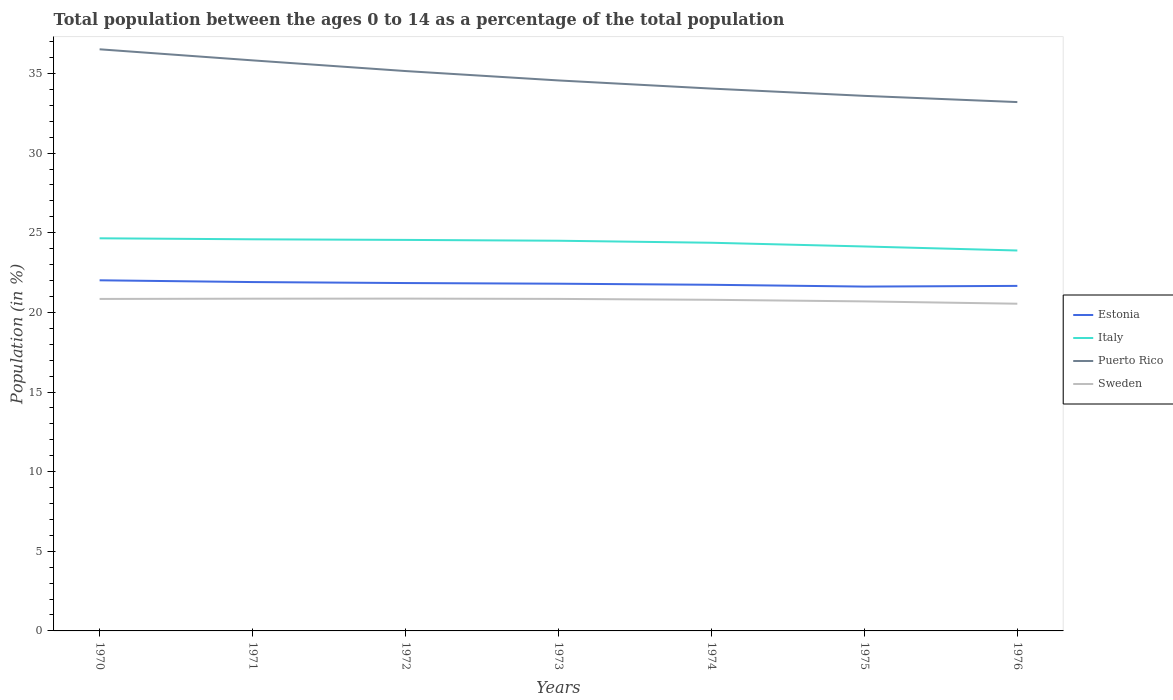Is the number of lines equal to the number of legend labels?
Keep it short and to the point. Yes. Across all years, what is the maximum percentage of the population ages 0 to 14 in Sweden?
Give a very brief answer. 20.55. In which year was the percentage of the population ages 0 to 14 in Estonia maximum?
Your answer should be very brief. 1975. What is the total percentage of the population ages 0 to 14 in Sweden in the graph?
Your answer should be very brief. 0.16. What is the difference between the highest and the second highest percentage of the population ages 0 to 14 in Puerto Rico?
Give a very brief answer. 3.31. What is the difference between the highest and the lowest percentage of the population ages 0 to 14 in Estonia?
Ensure brevity in your answer.  4. Is the percentage of the population ages 0 to 14 in Italy strictly greater than the percentage of the population ages 0 to 14 in Sweden over the years?
Give a very brief answer. No. How many years are there in the graph?
Your response must be concise. 7. Does the graph contain any zero values?
Your response must be concise. No. Where does the legend appear in the graph?
Your response must be concise. Center right. How many legend labels are there?
Offer a terse response. 4. How are the legend labels stacked?
Give a very brief answer. Vertical. What is the title of the graph?
Provide a succinct answer. Total population between the ages 0 to 14 as a percentage of the total population. What is the label or title of the X-axis?
Provide a short and direct response. Years. What is the label or title of the Y-axis?
Keep it short and to the point. Population (in %). What is the Population (in %) of Estonia in 1970?
Make the answer very short. 22.02. What is the Population (in %) of Italy in 1970?
Ensure brevity in your answer.  24.65. What is the Population (in %) in Puerto Rico in 1970?
Make the answer very short. 36.52. What is the Population (in %) of Sweden in 1970?
Provide a succinct answer. 20.85. What is the Population (in %) in Estonia in 1971?
Keep it short and to the point. 21.9. What is the Population (in %) in Italy in 1971?
Keep it short and to the point. 24.59. What is the Population (in %) in Puerto Rico in 1971?
Your answer should be very brief. 35.83. What is the Population (in %) in Sweden in 1971?
Offer a very short reply. 20.86. What is the Population (in %) of Estonia in 1972?
Make the answer very short. 21.84. What is the Population (in %) of Italy in 1972?
Your response must be concise. 24.55. What is the Population (in %) of Puerto Rico in 1972?
Offer a terse response. 35.15. What is the Population (in %) of Sweden in 1972?
Your response must be concise. 20.87. What is the Population (in %) of Estonia in 1973?
Ensure brevity in your answer.  21.8. What is the Population (in %) in Italy in 1973?
Make the answer very short. 24.5. What is the Population (in %) of Puerto Rico in 1973?
Make the answer very short. 34.56. What is the Population (in %) in Sweden in 1973?
Keep it short and to the point. 20.85. What is the Population (in %) of Estonia in 1974?
Ensure brevity in your answer.  21.73. What is the Population (in %) of Italy in 1974?
Offer a terse response. 24.37. What is the Population (in %) in Puerto Rico in 1974?
Your answer should be very brief. 34.05. What is the Population (in %) in Sweden in 1974?
Provide a succinct answer. 20.79. What is the Population (in %) of Estonia in 1975?
Keep it short and to the point. 21.62. What is the Population (in %) in Italy in 1975?
Keep it short and to the point. 24.14. What is the Population (in %) of Puerto Rico in 1975?
Your response must be concise. 33.6. What is the Population (in %) in Sweden in 1975?
Make the answer very short. 20.69. What is the Population (in %) in Estonia in 1976?
Ensure brevity in your answer.  21.66. What is the Population (in %) of Italy in 1976?
Your answer should be compact. 23.89. What is the Population (in %) in Puerto Rico in 1976?
Your answer should be compact. 33.21. What is the Population (in %) in Sweden in 1976?
Ensure brevity in your answer.  20.55. Across all years, what is the maximum Population (in %) in Estonia?
Make the answer very short. 22.02. Across all years, what is the maximum Population (in %) of Italy?
Your answer should be very brief. 24.65. Across all years, what is the maximum Population (in %) in Puerto Rico?
Keep it short and to the point. 36.52. Across all years, what is the maximum Population (in %) in Sweden?
Offer a very short reply. 20.87. Across all years, what is the minimum Population (in %) of Estonia?
Your answer should be very brief. 21.62. Across all years, what is the minimum Population (in %) of Italy?
Ensure brevity in your answer.  23.89. Across all years, what is the minimum Population (in %) in Puerto Rico?
Your response must be concise. 33.21. Across all years, what is the minimum Population (in %) in Sweden?
Offer a very short reply. 20.55. What is the total Population (in %) of Estonia in the graph?
Give a very brief answer. 152.58. What is the total Population (in %) of Italy in the graph?
Make the answer very short. 170.7. What is the total Population (in %) in Puerto Rico in the graph?
Keep it short and to the point. 242.92. What is the total Population (in %) in Sweden in the graph?
Offer a terse response. 145.45. What is the difference between the Population (in %) of Estonia in 1970 and that in 1971?
Offer a very short reply. 0.11. What is the difference between the Population (in %) of Italy in 1970 and that in 1971?
Offer a terse response. 0.06. What is the difference between the Population (in %) in Puerto Rico in 1970 and that in 1971?
Provide a short and direct response. 0.7. What is the difference between the Population (in %) in Sweden in 1970 and that in 1971?
Keep it short and to the point. -0.02. What is the difference between the Population (in %) in Estonia in 1970 and that in 1972?
Your answer should be very brief. 0.17. What is the difference between the Population (in %) in Italy in 1970 and that in 1972?
Provide a succinct answer. 0.1. What is the difference between the Population (in %) in Puerto Rico in 1970 and that in 1972?
Your answer should be very brief. 1.37. What is the difference between the Population (in %) in Sweden in 1970 and that in 1972?
Make the answer very short. -0.02. What is the difference between the Population (in %) of Estonia in 1970 and that in 1973?
Provide a succinct answer. 0.21. What is the difference between the Population (in %) of Italy in 1970 and that in 1973?
Keep it short and to the point. 0.15. What is the difference between the Population (in %) of Puerto Rico in 1970 and that in 1973?
Offer a very short reply. 1.96. What is the difference between the Population (in %) in Sweden in 1970 and that in 1973?
Your answer should be very brief. -0. What is the difference between the Population (in %) of Estonia in 1970 and that in 1974?
Provide a short and direct response. 0.28. What is the difference between the Population (in %) of Italy in 1970 and that in 1974?
Provide a succinct answer. 0.28. What is the difference between the Population (in %) in Puerto Rico in 1970 and that in 1974?
Your answer should be very brief. 2.47. What is the difference between the Population (in %) in Sweden in 1970 and that in 1974?
Ensure brevity in your answer.  0.05. What is the difference between the Population (in %) of Estonia in 1970 and that in 1975?
Provide a short and direct response. 0.39. What is the difference between the Population (in %) in Italy in 1970 and that in 1975?
Provide a succinct answer. 0.51. What is the difference between the Population (in %) of Puerto Rico in 1970 and that in 1975?
Your answer should be very brief. 2.92. What is the difference between the Population (in %) in Sweden in 1970 and that in 1975?
Make the answer very short. 0.15. What is the difference between the Population (in %) in Estonia in 1970 and that in 1976?
Keep it short and to the point. 0.35. What is the difference between the Population (in %) of Italy in 1970 and that in 1976?
Your answer should be compact. 0.77. What is the difference between the Population (in %) in Puerto Rico in 1970 and that in 1976?
Keep it short and to the point. 3.31. What is the difference between the Population (in %) of Sweden in 1970 and that in 1976?
Make the answer very short. 0.3. What is the difference between the Population (in %) of Estonia in 1971 and that in 1972?
Provide a short and direct response. 0.06. What is the difference between the Population (in %) of Italy in 1971 and that in 1972?
Give a very brief answer. 0.04. What is the difference between the Population (in %) in Puerto Rico in 1971 and that in 1972?
Provide a succinct answer. 0.67. What is the difference between the Population (in %) in Sweden in 1971 and that in 1972?
Provide a succinct answer. -0.01. What is the difference between the Population (in %) of Estonia in 1971 and that in 1973?
Provide a succinct answer. 0.1. What is the difference between the Population (in %) in Italy in 1971 and that in 1973?
Your response must be concise. 0.09. What is the difference between the Population (in %) of Puerto Rico in 1971 and that in 1973?
Your answer should be compact. 1.26. What is the difference between the Population (in %) of Sweden in 1971 and that in 1973?
Your answer should be compact. 0.01. What is the difference between the Population (in %) in Estonia in 1971 and that in 1974?
Provide a succinct answer. 0.17. What is the difference between the Population (in %) in Italy in 1971 and that in 1974?
Provide a short and direct response. 0.22. What is the difference between the Population (in %) in Puerto Rico in 1971 and that in 1974?
Provide a succinct answer. 1.77. What is the difference between the Population (in %) in Sweden in 1971 and that in 1974?
Make the answer very short. 0.07. What is the difference between the Population (in %) in Estonia in 1971 and that in 1975?
Your answer should be very brief. 0.28. What is the difference between the Population (in %) in Italy in 1971 and that in 1975?
Give a very brief answer. 0.45. What is the difference between the Population (in %) of Puerto Rico in 1971 and that in 1975?
Offer a very short reply. 2.23. What is the difference between the Population (in %) of Sweden in 1971 and that in 1975?
Keep it short and to the point. 0.17. What is the difference between the Population (in %) of Estonia in 1971 and that in 1976?
Provide a short and direct response. 0.24. What is the difference between the Population (in %) in Italy in 1971 and that in 1976?
Your answer should be compact. 0.7. What is the difference between the Population (in %) in Puerto Rico in 1971 and that in 1976?
Offer a very short reply. 2.62. What is the difference between the Population (in %) in Sweden in 1971 and that in 1976?
Offer a terse response. 0.32. What is the difference between the Population (in %) of Estonia in 1972 and that in 1973?
Offer a terse response. 0.04. What is the difference between the Population (in %) in Italy in 1972 and that in 1973?
Your answer should be very brief. 0.05. What is the difference between the Population (in %) of Puerto Rico in 1972 and that in 1973?
Make the answer very short. 0.59. What is the difference between the Population (in %) in Sweden in 1972 and that in 1973?
Make the answer very short. 0.02. What is the difference between the Population (in %) of Estonia in 1972 and that in 1974?
Keep it short and to the point. 0.11. What is the difference between the Population (in %) in Italy in 1972 and that in 1974?
Keep it short and to the point. 0.18. What is the difference between the Population (in %) of Puerto Rico in 1972 and that in 1974?
Offer a very short reply. 1.1. What is the difference between the Population (in %) in Sweden in 1972 and that in 1974?
Your answer should be compact. 0.07. What is the difference between the Population (in %) in Estonia in 1972 and that in 1975?
Keep it short and to the point. 0.22. What is the difference between the Population (in %) in Italy in 1972 and that in 1975?
Offer a terse response. 0.41. What is the difference between the Population (in %) in Puerto Rico in 1972 and that in 1975?
Ensure brevity in your answer.  1.56. What is the difference between the Population (in %) in Sweden in 1972 and that in 1975?
Keep it short and to the point. 0.17. What is the difference between the Population (in %) of Estonia in 1972 and that in 1976?
Your answer should be compact. 0.18. What is the difference between the Population (in %) in Italy in 1972 and that in 1976?
Your response must be concise. 0.67. What is the difference between the Population (in %) of Puerto Rico in 1972 and that in 1976?
Provide a succinct answer. 1.95. What is the difference between the Population (in %) in Sweden in 1972 and that in 1976?
Provide a short and direct response. 0.32. What is the difference between the Population (in %) of Estonia in 1973 and that in 1974?
Make the answer very short. 0.07. What is the difference between the Population (in %) of Italy in 1973 and that in 1974?
Your response must be concise. 0.13. What is the difference between the Population (in %) in Puerto Rico in 1973 and that in 1974?
Ensure brevity in your answer.  0.51. What is the difference between the Population (in %) of Sweden in 1973 and that in 1974?
Your answer should be very brief. 0.06. What is the difference between the Population (in %) of Estonia in 1973 and that in 1975?
Give a very brief answer. 0.18. What is the difference between the Population (in %) of Italy in 1973 and that in 1975?
Make the answer very short. 0.36. What is the difference between the Population (in %) in Puerto Rico in 1973 and that in 1975?
Offer a very short reply. 0.97. What is the difference between the Population (in %) in Sweden in 1973 and that in 1975?
Offer a very short reply. 0.16. What is the difference between the Population (in %) of Estonia in 1973 and that in 1976?
Provide a succinct answer. 0.14. What is the difference between the Population (in %) of Italy in 1973 and that in 1976?
Offer a very short reply. 0.61. What is the difference between the Population (in %) of Puerto Rico in 1973 and that in 1976?
Keep it short and to the point. 1.36. What is the difference between the Population (in %) of Sweden in 1973 and that in 1976?
Offer a terse response. 0.3. What is the difference between the Population (in %) in Estonia in 1974 and that in 1975?
Provide a short and direct response. 0.11. What is the difference between the Population (in %) of Italy in 1974 and that in 1975?
Ensure brevity in your answer.  0.23. What is the difference between the Population (in %) of Puerto Rico in 1974 and that in 1975?
Offer a terse response. 0.46. What is the difference between the Population (in %) in Sweden in 1974 and that in 1975?
Give a very brief answer. 0.1. What is the difference between the Population (in %) of Estonia in 1974 and that in 1976?
Your response must be concise. 0.07. What is the difference between the Population (in %) of Italy in 1974 and that in 1976?
Keep it short and to the point. 0.49. What is the difference between the Population (in %) in Puerto Rico in 1974 and that in 1976?
Your answer should be very brief. 0.85. What is the difference between the Population (in %) of Sweden in 1974 and that in 1976?
Offer a terse response. 0.25. What is the difference between the Population (in %) in Estonia in 1975 and that in 1976?
Offer a terse response. -0.04. What is the difference between the Population (in %) in Italy in 1975 and that in 1976?
Make the answer very short. 0.25. What is the difference between the Population (in %) in Puerto Rico in 1975 and that in 1976?
Provide a short and direct response. 0.39. What is the difference between the Population (in %) in Sweden in 1975 and that in 1976?
Provide a short and direct response. 0.15. What is the difference between the Population (in %) in Estonia in 1970 and the Population (in %) in Italy in 1971?
Your answer should be very brief. -2.58. What is the difference between the Population (in %) of Estonia in 1970 and the Population (in %) of Puerto Rico in 1971?
Your answer should be very brief. -13.81. What is the difference between the Population (in %) of Estonia in 1970 and the Population (in %) of Sweden in 1971?
Ensure brevity in your answer.  1.15. What is the difference between the Population (in %) of Italy in 1970 and the Population (in %) of Puerto Rico in 1971?
Give a very brief answer. -11.17. What is the difference between the Population (in %) in Italy in 1970 and the Population (in %) in Sweden in 1971?
Offer a very short reply. 3.79. What is the difference between the Population (in %) of Puerto Rico in 1970 and the Population (in %) of Sweden in 1971?
Your response must be concise. 15.66. What is the difference between the Population (in %) in Estonia in 1970 and the Population (in %) in Italy in 1972?
Provide a short and direct response. -2.54. What is the difference between the Population (in %) in Estonia in 1970 and the Population (in %) in Puerto Rico in 1972?
Offer a terse response. -13.14. What is the difference between the Population (in %) of Estonia in 1970 and the Population (in %) of Sweden in 1972?
Offer a very short reply. 1.15. What is the difference between the Population (in %) of Italy in 1970 and the Population (in %) of Puerto Rico in 1972?
Keep it short and to the point. -10.5. What is the difference between the Population (in %) in Italy in 1970 and the Population (in %) in Sweden in 1972?
Give a very brief answer. 3.79. What is the difference between the Population (in %) in Puerto Rico in 1970 and the Population (in %) in Sweden in 1972?
Ensure brevity in your answer.  15.65. What is the difference between the Population (in %) of Estonia in 1970 and the Population (in %) of Italy in 1973?
Keep it short and to the point. -2.48. What is the difference between the Population (in %) in Estonia in 1970 and the Population (in %) in Puerto Rico in 1973?
Ensure brevity in your answer.  -12.55. What is the difference between the Population (in %) of Estonia in 1970 and the Population (in %) of Sweden in 1973?
Keep it short and to the point. 1.17. What is the difference between the Population (in %) in Italy in 1970 and the Population (in %) in Puerto Rico in 1973?
Provide a short and direct response. -9.91. What is the difference between the Population (in %) of Italy in 1970 and the Population (in %) of Sweden in 1973?
Offer a very short reply. 3.81. What is the difference between the Population (in %) in Puerto Rico in 1970 and the Population (in %) in Sweden in 1973?
Offer a very short reply. 15.67. What is the difference between the Population (in %) of Estonia in 1970 and the Population (in %) of Italy in 1974?
Keep it short and to the point. -2.36. What is the difference between the Population (in %) in Estonia in 1970 and the Population (in %) in Puerto Rico in 1974?
Your answer should be compact. -12.04. What is the difference between the Population (in %) of Estonia in 1970 and the Population (in %) of Sweden in 1974?
Ensure brevity in your answer.  1.22. What is the difference between the Population (in %) of Italy in 1970 and the Population (in %) of Puerto Rico in 1974?
Keep it short and to the point. -9.4. What is the difference between the Population (in %) in Italy in 1970 and the Population (in %) in Sweden in 1974?
Ensure brevity in your answer.  3.86. What is the difference between the Population (in %) in Puerto Rico in 1970 and the Population (in %) in Sweden in 1974?
Provide a succinct answer. 15.73. What is the difference between the Population (in %) in Estonia in 1970 and the Population (in %) in Italy in 1975?
Make the answer very short. -2.12. What is the difference between the Population (in %) in Estonia in 1970 and the Population (in %) in Puerto Rico in 1975?
Give a very brief answer. -11.58. What is the difference between the Population (in %) in Estonia in 1970 and the Population (in %) in Sweden in 1975?
Your answer should be very brief. 1.32. What is the difference between the Population (in %) in Italy in 1970 and the Population (in %) in Puerto Rico in 1975?
Offer a terse response. -8.94. What is the difference between the Population (in %) of Italy in 1970 and the Population (in %) of Sweden in 1975?
Offer a very short reply. 3.96. What is the difference between the Population (in %) in Puerto Rico in 1970 and the Population (in %) in Sweden in 1975?
Make the answer very short. 15.83. What is the difference between the Population (in %) in Estonia in 1970 and the Population (in %) in Italy in 1976?
Your answer should be very brief. -1.87. What is the difference between the Population (in %) in Estonia in 1970 and the Population (in %) in Puerto Rico in 1976?
Offer a very short reply. -11.19. What is the difference between the Population (in %) in Estonia in 1970 and the Population (in %) in Sweden in 1976?
Your response must be concise. 1.47. What is the difference between the Population (in %) in Italy in 1970 and the Population (in %) in Puerto Rico in 1976?
Your answer should be compact. -8.55. What is the difference between the Population (in %) in Italy in 1970 and the Population (in %) in Sweden in 1976?
Provide a succinct answer. 4.11. What is the difference between the Population (in %) in Puerto Rico in 1970 and the Population (in %) in Sweden in 1976?
Your answer should be compact. 15.98. What is the difference between the Population (in %) of Estonia in 1971 and the Population (in %) of Italy in 1972?
Provide a succinct answer. -2.65. What is the difference between the Population (in %) in Estonia in 1971 and the Population (in %) in Puerto Rico in 1972?
Provide a succinct answer. -13.25. What is the difference between the Population (in %) in Estonia in 1971 and the Population (in %) in Sweden in 1972?
Offer a very short reply. 1.04. What is the difference between the Population (in %) of Italy in 1971 and the Population (in %) of Puerto Rico in 1972?
Provide a succinct answer. -10.56. What is the difference between the Population (in %) in Italy in 1971 and the Population (in %) in Sweden in 1972?
Your answer should be compact. 3.72. What is the difference between the Population (in %) in Puerto Rico in 1971 and the Population (in %) in Sweden in 1972?
Your response must be concise. 14.96. What is the difference between the Population (in %) in Estonia in 1971 and the Population (in %) in Italy in 1973?
Give a very brief answer. -2.59. What is the difference between the Population (in %) of Estonia in 1971 and the Population (in %) of Puerto Rico in 1973?
Provide a short and direct response. -12.66. What is the difference between the Population (in %) of Estonia in 1971 and the Population (in %) of Sweden in 1973?
Your answer should be compact. 1.06. What is the difference between the Population (in %) in Italy in 1971 and the Population (in %) in Puerto Rico in 1973?
Provide a short and direct response. -9.97. What is the difference between the Population (in %) in Italy in 1971 and the Population (in %) in Sweden in 1973?
Keep it short and to the point. 3.74. What is the difference between the Population (in %) in Puerto Rico in 1971 and the Population (in %) in Sweden in 1973?
Provide a succinct answer. 14.98. What is the difference between the Population (in %) of Estonia in 1971 and the Population (in %) of Italy in 1974?
Offer a terse response. -2.47. What is the difference between the Population (in %) in Estonia in 1971 and the Population (in %) in Puerto Rico in 1974?
Offer a very short reply. -12.15. What is the difference between the Population (in %) of Estonia in 1971 and the Population (in %) of Sweden in 1974?
Keep it short and to the point. 1.11. What is the difference between the Population (in %) of Italy in 1971 and the Population (in %) of Puerto Rico in 1974?
Offer a very short reply. -9.46. What is the difference between the Population (in %) in Italy in 1971 and the Population (in %) in Sweden in 1974?
Offer a very short reply. 3.8. What is the difference between the Population (in %) in Puerto Rico in 1971 and the Population (in %) in Sweden in 1974?
Give a very brief answer. 15.03. What is the difference between the Population (in %) of Estonia in 1971 and the Population (in %) of Italy in 1975?
Offer a terse response. -2.23. What is the difference between the Population (in %) in Estonia in 1971 and the Population (in %) in Puerto Rico in 1975?
Offer a very short reply. -11.69. What is the difference between the Population (in %) in Estonia in 1971 and the Population (in %) in Sweden in 1975?
Your response must be concise. 1.21. What is the difference between the Population (in %) in Italy in 1971 and the Population (in %) in Puerto Rico in 1975?
Provide a short and direct response. -9.01. What is the difference between the Population (in %) of Italy in 1971 and the Population (in %) of Sweden in 1975?
Your answer should be very brief. 3.9. What is the difference between the Population (in %) of Puerto Rico in 1971 and the Population (in %) of Sweden in 1975?
Offer a very short reply. 15.13. What is the difference between the Population (in %) in Estonia in 1971 and the Population (in %) in Italy in 1976?
Provide a short and direct response. -1.98. What is the difference between the Population (in %) of Estonia in 1971 and the Population (in %) of Puerto Rico in 1976?
Offer a very short reply. -11.3. What is the difference between the Population (in %) in Estonia in 1971 and the Population (in %) in Sweden in 1976?
Keep it short and to the point. 1.36. What is the difference between the Population (in %) in Italy in 1971 and the Population (in %) in Puerto Rico in 1976?
Ensure brevity in your answer.  -8.62. What is the difference between the Population (in %) of Italy in 1971 and the Population (in %) of Sweden in 1976?
Your answer should be compact. 4.05. What is the difference between the Population (in %) in Puerto Rico in 1971 and the Population (in %) in Sweden in 1976?
Make the answer very short. 15.28. What is the difference between the Population (in %) of Estonia in 1972 and the Population (in %) of Italy in 1973?
Offer a terse response. -2.66. What is the difference between the Population (in %) of Estonia in 1972 and the Population (in %) of Puerto Rico in 1973?
Give a very brief answer. -12.72. What is the difference between the Population (in %) of Estonia in 1972 and the Population (in %) of Sweden in 1973?
Make the answer very short. 1. What is the difference between the Population (in %) of Italy in 1972 and the Population (in %) of Puerto Rico in 1973?
Make the answer very short. -10.01. What is the difference between the Population (in %) of Italy in 1972 and the Population (in %) of Sweden in 1973?
Offer a terse response. 3.71. What is the difference between the Population (in %) of Puerto Rico in 1972 and the Population (in %) of Sweden in 1973?
Give a very brief answer. 14.31. What is the difference between the Population (in %) of Estonia in 1972 and the Population (in %) of Italy in 1974?
Your response must be concise. -2.53. What is the difference between the Population (in %) in Estonia in 1972 and the Population (in %) in Puerto Rico in 1974?
Provide a short and direct response. -12.21. What is the difference between the Population (in %) of Estonia in 1972 and the Population (in %) of Sweden in 1974?
Keep it short and to the point. 1.05. What is the difference between the Population (in %) of Italy in 1972 and the Population (in %) of Puerto Rico in 1974?
Make the answer very short. -9.5. What is the difference between the Population (in %) of Italy in 1972 and the Population (in %) of Sweden in 1974?
Your response must be concise. 3.76. What is the difference between the Population (in %) in Puerto Rico in 1972 and the Population (in %) in Sweden in 1974?
Give a very brief answer. 14.36. What is the difference between the Population (in %) in Estonia in 1972 and the Population (in %) in Italy in 1975?
Provide a short and direct response. -2.3. What is the difference between the Population (in %) of Estonia in 1972 and the Population (in %) of Puerto Rico in 1975?
Make the answer very short. -11.75. What is the difference between the Population (in %) of Estonia in 1972 and the Population (in %) of Sweden in 1975?
Offer a very short reply. 1.15. What is the difference between the Population (in %) in Italy in 1972 and the Population (in %) in Puerto Rico in 1975?
Make the answer very short. -9.04. What is the difference between the Population (in %) of Italy in 1972 and the Population (in %) of Sweden in 1975?
Give a very brief answer. 3.86. What is the difference between the Population (in %) in Puerto Rico in 1972 and the Population (in %) in Sweden in 1975?
Keep it short and to the point. 14.46. What is the difference between the Population (in %) in Estonia in 1972 and the Population (in %) in Italy in 1976?
Give a very brief answer. -2.04. What is the difference between the Population (in %) of Estonia in 1972 and the Population (in %) of Puerto Rico in 1976?
Your answer should be compact. -11.36. What is the difference between the Population (in %) of Estonia in 1972 and the Population (in %) of Sweden in 1976?
Give a very brief answer. 1.3. What is the difference between the Population (in %) of Italy in 1972 and the Population (in %) of Puerto Rico in 1976?
Offer a very short reply. -8.65. What is the difference between the Population (in %) of Italy in 1972 and the Population (in %) of Sweden in 1976?
Provide a short and direct response. 4.01. What is the difference between the Population (in %) in Puerto Rico in 1972 and the Population (in %) in Sweden in 1976?
Offer a terse response. 14.61. What is the difference between the Population (in %) in Estonia in 1973 and the Population (in %) in Italy in 1974?
Provide a succinct answer. -2.57. What is the difference between the Population (in %) of Estonia in 1973 and the Population (in %) of Puerto Rico in 1974?
Make the answer very short. -12.25. What is the difference between the Population (in %) of Estonia in 1973 and the Population (in %) of Sweden in 1974?
Make the answer very short. 1.01. What is the difference between the Population (in %) of Italy in 1973 and the Population (in %) of Puerto Rico in 1974?
Your answer should be compact. -9.55. What is the difference between the Population (in %) of Italy in 1973 and the Population (in %) of Sweden in 1974?
Make the answer very short. 3.71. What is the difference between the Population (in %) in Puerto Rico in 1973 and the Population (in %) in Sweden in 1974?
Your answer should be very brief. 13.77. What is the difference between the Population (in %) in Estonia in 1973 and the Population (in %) in Italy in 1975?
Keep it short and to the point. -2.34. What is the difference between the Population (in %) in Estonia in 1973 and the Population (in %) in Puerto Rico in 1975?
Ensure brevity in your answer.  -11.79. What is the difference between the Population (in %) of Estonia in 1973 and the Population (in %) of Sweden in 1975?
Make the answer very short. 1.11. What is the difference between the Population (in %) of Italy in 1973 and the Population (in %) of Puerto Rico in 1975?
Keep it short and to the point. -9.1. What is the difference between the Population (in %) of Italy in 1973 and the Population (in %) of Sweden in 1975?
Offer a terse response. 3.81. What is the difference between the Population (in %) of Puerto Rico in 1973 and the Population (in %) of Sweden in 1975?
Provide a succinct answer. 13.87. What is the difference between the Population (in %) of Estonia in 1973 and the Population (in %) of Italy in 1976?
Your answer should be compact. -2.08. What is the difference between the Population (in %) in Estonia in 1973 and the Population (in %) in Puerto Rico in 1976?
Your response must be concise. -11.4. What is the difference between the Population (in %) of Estonia in 1973 and the Population (in %) of Sweden in 1976?
Your answer should be very brief. 1.26. What is the difference between the Population (in %) of Italy in 1973 and the Population (in %) of Puerto Rico in 1976?
Ensure brevity in your answer.  -8.71. What is the difference between the Population (in %) in Italy in 1973 and the Population (in %) in Sweden in 1976?
Your response must be concise. 3.95. What is the difference between the Population (in %) of Puerto Rico in 1973 and the Population (in %) of Sweden in 1976?
Give a very brief answer. 14.02. What is the difference between the Population (in %) in Estonia in 1974 and the Population (in %) in Italy in 1975?
Keep it short and to the point. -2.41. What is the difference between the Population (in %) of Estonia in 1974 and the Population (in %) of Puerto Rico in 1975?
Provide a succinct answer. -11.86. What is the difference between the Population (in %) in Estonia in 1974 and the Population (in %) in Sweden in 1975?
Give a very brief answer. 1.04. What is the difference between the Population (in %) in Italy in 1974 and the Population (in %) in Puerto Rico in 1975?
Provide a short and direct response. -9.22. What is the difference between the Population (in %) of Italy in 1974 and the Population (in %) of Sweden in 1975?
Make the answer very short. 3.68. What is the difference between the Population (in %) of Puerto Rico in 1974 and the Population (in %) of Sweden in 1975?
Offer a very short reply. 13.36. What is the difference between the Population (in %) of Estonia in 1974 and the Population (in %) of Italy in 1976?
Offer a terse response. -2.15. What is the difference between the Population (in %) in Estonia in 1974 and the Population (in %) in Puerto Rico in 1976?
Your answer should be very brief. -11.47. What is the difference between the Population (in %) in Estonia in 1974 and the Population (in %) in Sweden in 1976?
Provide a succinct answer. 1.19. What is the difference between the Population (in %) of Italy in 1974 and the Population (in %) of Puerto Rico in 1976?
Offer a very short reply. -8.83. What is the difference between the Population (in %) of Italy in 1974 and the Population (in %) of Sweden in 1976?
Your answer should be compact. 3.83. What is the difference between the Population (in %) in Puerto Rico in 1974 and the Population (in %) in Sweden in 1976?
Provide a short and direct response. 13.51. What is the difference between the Population (in %) in Estonia in 1975 and the Population (in %) in Italy in 1976?
Your answer should be compact. -2.27. What is the difference between the Population (in %) of Estonia in 1975 and the Population (in %) of Puerto Rico in 1976?
Offer a very short reply. -11.59. What is the difference between the Population (in %) in Estonia in 1975 and the Population (in %) in Sweden in 1976?
Offer a terse response. 1.08. What is the difference between the Population (in %) of Italy in 1975 and the Population (in %) of Puerto Rico in 1976?
Offer a very short reply. -9.07. What is the difference between the Population (in %) in Italy in 1975 and the Population (in %) in Sweden in 1976?
Make the answer very short. 3.59. What is the difference between the Population (in %) of Puerto Rico in 1975 and the Population (in %) of Sweden in 1976?
Offer a very short reply. 13.05. What is the average Population (in %) of Estonia per year?
Your answer should be very brief. 21.8. What is the average Population (in %) of Italy per year?
Provide a succinct answer. 24.39. What is the average Population (in %) in Puerto Rico per year?
Your answer should be very brief. 34.7. What is the average Population (in %) of Sweden per year?
Give a very brief answer. 20.78. In the year 1970, what is the difference between the Population (in %) of Estonia and Population (in %) of Italy?
Keep it short and to the point. -2.64. In the year 1970, what is the difference between the Population (in %) in Estonia and Population (in %) in Puerto Rico?
Provide a succinct answer. -14.51. In the year 1970, what is the difference between the Population (in %) in Estonia and Population (in %) in Sweden?
Your response must be concise. 1.17. In the year 1970, what is the difference between the Population (in %) in Italy and Population (in %) in Puerto Rico?
Provide a short and direct response. -11.87. In the year 1970, what is the difference between the Population (in %) in Italy and Population (in %) in Sweden?
Offer a very short reply. 3.81. In the year 1970, what is the difference between the Population (in %) of Puerto Rico and Population (in %) of Sweden?
Your answer should be compact. 15.68. In the year 1971, what is the difference between the Population (in %) of Estonia and Population (in %) of Italy?
Offer a terse response. -2.69. In the year 1971, what is the difference between the Population (in %) in Estonia and Population (in %) in Puerto Rico?
Offer a terse response. -13.92. In the year 1971, what is the difference between the Population (in %) of Estonia and Population (in %) of Sweden?
Ensure brevity in your answer.  1.04. In the year 1971, what is the difference between the Population (in %) in Italy and Population (in %) in Puerto Rico?
Keep it short and to the point. -11.23. In the year 1971, what is the difference between the Population (in %) in Italy and Population (in %) in Sweden?
Offer a terse response. 3.73. In the year 1971, what is the difference between the Population (in %) of Puerto Rico and Population (in %) of Sweden?
Give a very brief answer. 14.96. In the year 1972, what is the difference between the Population (in %) of Estonia and Population (in %) of Italy?
Offer a very short reply. -2.71. In the year 1972, what is the difference between the Population (in %) of Estonia and Population (in %) of Puerto Rico?
Make the answer very short. -13.31. In the year 1972, what is the difference between the Population (in %) in Estonia and Population (in %) in Sweden?
Offer a terse response. 0.98. In the year 1972, what is the difference between the Population (in %) in Italy and Population (in %) in Puerto Rico?
Provide a short and direct response. -10.6. In the year 1972, what is the difference between the Population (in %) in Italy and Population (in %) in Sweden?
Keep it short and to the point. 3.69. In the year 1972, what is the difference between the Population (in %) in Puerto Rico and Population (in %) in Sweden?
Offer a very short reply. 14.29. In the year 1973, what is the difference between the Population (in %) of Estonia and Population (in %) of Italy?
Give a very brief answer. -2.7. In the year 1973, what is the difference between the Population (in %) of Estonia and Population (in %) of Puerto Rico?
Offer a terse response. -12.76. In the year 1973, what is the difference between the Population (in %) in Estonia and Population (in %) in Sweden?
Give a very brief answer. 0.95. In the year 1973, what is the difference between the Population (in %) of Italy and Population (in %) of Puerto Rico?
Ensure brevity in your answer.  -10.07. In the year 1973, what is the difference between the Population (in %) in Italy and Population (in %) in Sweden?
Your response must be concise. 3.65. In the year 1973, what is the difference between the Population (in %) of Puerto Rico and Population (in %) of Sweden?
Provide a succinct answer. 13.72. In the year 1974, what is the difference between the Population (in %) in Estonia and Population (in %) in Italy?
Your answer should be very brief. -2.64. In the year 1974, what is the difference between the Population (in %) of Estonia and Population (in %) of Puerto Rico?
Provide a short and direct response. -12.32. In the year 1974, what is the difference between the Population (in %) in Estonia and Population (in %) in Sweden?
Your answer should be very brief. 0.94. In the year 1974, what is the difference between the Population (in %) in Italy and Population (in %) in Puerto Rico?
Offer a very short reply. -9.68. In the year 1974, what is the difference between the Population (in %) of Italy and Population (in %) of Sweden?
Your answer should be very brief. 3.58. In the year 1974, what is the difference between the Population (in %) of Puerto Rico and Population (in %) of Sweden?
Offer a terse response. 13.26. In the year 1975, what is the difference between the Population (in %) of Estonia and Population (in %) of Italy?
Offer a very short reply. -2.52. In the year 1975, what is the difference between the Population (in %) in Estonia and Population (in %) in Puerto Rico?
Your response must be concise. -11.98. In the year 1975, what is the difference between the Population (in %) in Estonia and Population (in %) in Sweden?
Your response must be concise. 0.93. In the year 1975, what is the difference between the Population (in %) of Italy and Population (in %) of Puerto Rico?
Your answer should be compact. -9.46. In the year 1975, what is the difference between the Population (in %) of Italy and Population (in %) of Sweden?
Your answer should be very brief. 3.45. In the year 1975, what is the difference between the Population (in %) of Puerto Rico and Population (in %) of Sweden?
Make the answer very short. 12.9. In the year 1976, what is the difference between the Population (in %) in Estonia and Population (in %) in Italy?
Make the answer very short. -2.22. In the year 1976, what is the difference between the Population (in %) of Estonia and Population (in %) of Puerto Rico?
Give a very brief answer. -11.54. In the year 1976, what is the difference between the Population (in %) of Estonia and Population (in %) of Sweden?
Keep it short and to the point. 1.12. In the year 1976, what is the difference between the Population (in %) in Italy and Population (in %) in Puerto Rico?
Offer a very short reply. -9.32. In the year 1976, what is the difference between the Population (in %) of Italy and Population (in %) of Sweden?
Your answer should be very brief. 3.34. In the year 1976, what is the difference between the Population (in %) in Puerto Rico and Population (in %) in Sweden?
Offer a very short reply. 12.66. What is the ratio of the Population (in %) of Estonia in 1970 to that in 1971?
Offer a terse response. 1. What is the ratio of the Population (in %) in Puerto Rico in 1970 to that in 1971?
Provide a succinct answer. 1.02. What is the ratio of the Population (in %) in Sweden in 1970 to that in 1971?
Offer a very short reply. 1. What is the ratio of the Population (in %) in Estonia in 1970 to that in 1972?
Your response must be concise. 1.01. What is the ratio of the Population (in %) of Puerto Rico in 1970 to that in 1972?
Offer a very short reply. 1.04. What is the ratio of the Population (in %) of Estonia in 1970 to that in 1973?
Ensure brevity in your answer.  1.01. What is the ratio of the Population (in %) in Puerto Rico in 1970 to that in 1973?
Give a very brief answer. 1.06. What is the ratio of the Population (in %) in Sweden in 1970 to that in 1973?
Provide a succinct answer. 1. What is the ratio of the Population (in %) of Estonia in 1970 to that in 1974?
Offer a terse response. 1.01. What is the ratio of the Population (in %) in Italy in 1970 to that in 1974?
Ensure brevity in your answer.  1.01. What is the ratio of the Population (in %) in Puerto Rico in 1970 to that in 1974?
Keep it short and to the point. 1.07. What is the ratio of the Population (in %) in Estonia in 1970 to that in 1975?
Keep it short and to the point. 1.02. What is the ratio of the Population (in %) in Italy in 1970 to that in 1975?
Your answer should be very brief. 1.02. What is the ratio of the Population (in %) in Puerto Rico in 1970 to that in 1975?
Give a very brief answer. 1.09. What is the ratio of the Population (in %) in Sweden in 1970 to that in 1975?
Your answer should be very brief. 1.01. What is the ratio of the Population (in %) of Estonia in 1970 to that in 1976?
Make the answer very short. 1.02. What is the ratio of the Population (in %) of Italy in 1970 to that in 1976?
Offer a very short reply. 1.03. What is the ratio of the Population (in %) of Puerto Rico in 1970 to that in 1976?
Offer a terse response. 1.1. What is the ratio of the Population (in %) in Sweden in 1970 to that in 1976?
Give a very brief answer. 1.01. What is the ratio of the Population (in %) of Estonia in 1971 to that in 1972?
Ensure brevity in your answer.  1. What is the ratio of the Population (in %) of Italy in 1971 to that in 1972?
Ensure brevity in your answer.  1. What is the ratio of the Population (in %) in Puerto Rico in 1971 to that in 1972?
Your answer should be compact. 1.02. What is the ratio of the Population (in %) in Sweden in 1971 to that in 1972?
Give a very brief answer. 1. What is the ratio of the Population (in %) of Italy in 1971 to that in 1973?
Your answer should be compact. 1. What is the ratio of the Population (in %) in Puerto Rico in 1971 to that in 1973?
Keep it short and to the point. 1.04. What is the ratio of the Population (in %) of Sweden in 1971 to that in 1973?
Offer a very short reply. 1. What is the ratio of the Population (in %) of Estonia in 1971 to that in 1974?
Offer a very short reply. 1.01. What is the ratio of the Population (in %) in Italy in 1971 to that in 1974?
Make the answer very short. 1.01. What is the ratio of the Population (in %) of Puerto Rico in 1971 to that in 1974?
Provide a short and direct response. 1.05. What is the ratio of the Population (in %) of Sweden in 1971 to that in 1974?
Offer a very short reply. 1. What is the ratio of the Population (in %) of Estonia in 1971 to that in 1975?
Keep it short and to the point. 1.01. What is the ratio of the Population (in %) of Italy in 1971 to that in 1975?
Give a very brief answer. 1.02. What is the ratio of the Population (in %) of Puerto Rico in 1971 to that in 1975?
Your answer should be compact. 1.07. What is the ratio of the Population (in %) of Sweden in 1971 to that in 1975?
Your response must be concise. 1.01. What is the ratio of the Population (in %) of Estonia in 1971 to that in 1976?
Your answer should be very brief. 1.01. What is the ratio of the Population (in %) of Italy in 1971 to that in 1976?
Your answer should be compact. 1.03. What is the ratio of the Population (in %) of Puerto Rico in 1971 to that in 1976?
Provide a short and direct response. 1.08. What is the ratio of the Population (in %) in Sweden in 1971 to that in 1976?
Keep it short and to the point. 1.02. What is the ratio of the Population (in %) in Estonia in 1972 to that in 1973?
Your answer should be compact. 1. What is the ratio of the Population (in %) of Puerto Rico in 1972 to that in 1973?
Make the answer very short. 1.02. What is the ratio of the Population (in %) of Estonia in 1972 to that in 1974?
Your response must be concise. 1. What is the ratio of the Population (in %) of Italy in 1972 to that in 1974?
Provide a short and direct response. 1.01. What is the ratio of the Population (in %) of Puerto Rico in 1972 to that in 1974?
Your answer should be very brief. 1.03. What is the ratio of the Population (in %) in Sweden in 1972 to that in 1974?
Make the answer very short. 1. What is the ratio of the Population (in %) of Estonia in 1972 to that in 1975?
Your answer should be compact. 1.01. What is the ratio of the Population (in %) of Italy in 1972 to that in 1975?
Keep it short and to the point. 1.02. What is the ratio of the Population (in %) in Puerto Rico in 1972 to that in 1975?
Provide a short and direct response. 1.05. What is the ratio of the Population (in %) in Sweden in 1972 to that in 1975?
Make the answer very short. 1.01. What is the ratio of the Population (in %) of Estonia in 1972 to that in 1976?
Provide a succinct answer. 1.01. What is the ratio of the Population (in %) in Italy in 1972 to that in 1976?
Provide a short and direct response. 1.03. What is the ratio of the Population (in %) in Puerto Rico in 1972 to that in 1976?
Your response must be concise. 1.06. What is the ratio of the Population (in %) in Sweden in 1972 to that in 1976?
Give a very brief answer. 1.02. What is the ratio of the Population (in %) in Estonia in 1973 to that in 1974?
Give a very brief answer. 1. What is the ratio of the Population (in %) in Italy in 1973 to that in 1974?
Offer a terse response. 1.01. What is the ratio of the Population (in %) in Sweden in 1973 to that in 1974?
Ensure brevity in your answer.  1. What is the ratio of the Population (in %) of Estonia in 1973 to that in 1975?
Provide a succinct answer. 1.01. What is the ratio of the Population (in %) of Italy in 1973 to that in 1975?
Ensure brevity in your answer.  1.01. What is the ratio of the Population (in %) of Puerto Rico in 1973 to that in 1975?
Provide a short and direct response. 1.03. What is the ratio of the Population (in %) in Sweden in 1973 to that in 1975?
Provide a succinct answer. 1.01. What is the ratio of the Population (in %) of Estonia in 1973 to that in 1976?
Give a very brief answer. 1.01. What is the ratio of the Population (in %) of Italy in 1973 to that in 1976?
Keep it short and to the point. 1.03. What is the ratio of the Population (in %) in Puerto Rico in 1973 to that in 1976?
Make the answer very short. 1.04. What is the ratio of the Population (in %) of Sweden in 1973 to that in 1976?
Your answer should be very brief. 1.01. What is the ratio of the Population (in %) of Estonia in 1974 to that in 1975?
Provide a succinct answer. 1.01. What is the ratio of the Population (in %) in Italy in 1974 to that in 1975?
Offer a terse response. 1.01. What is the ratio of the Population (in %) in Puerto Rico in 1974 to that in 1975?
Offer a terse response. 1.01. What is the ratio of the Population (in %) of Sweden in 1974 to that in 1975?
Keep it short and to the point. 1. What is the ratio of the Population (in %) of Estonia in 1974 to that in 1976?
Offer a very short reply. 1. What is the ratio of the Population (in %) in Italy in 1974 to that in 1976?
Your response must be concise. 1.02. What is the ratio of the Population (in %) in Puerto Rico in 1974 to that in 1976?
Offer a terse response. 1.03. What is the ratio of the Population (in %) of Sweden in 1974 to that in 1976?
Ensure brevity in your answer.  1.01. What is the ratio of the Population (in %) of Estonia in 1975 to that in 1976?
Make the answer very short. 1. What is the ratio of the Population (in %) in Italy in 1975 to that in 1976?
Give a very brief answer. 1.01. What is the ratio of the Population (in %) of Puerto Rico in 1975 to that in 1976?
Keep it short and to the point. 1.01. What is the ratio of the Population (in %) of Sweden in 1975 to that in 1976?
Your answer should be very brief. 1.01. What is the difference between the highest and the second highest Population (in %) of Estonia?
Give a very brief answer. 0.11. What is the difference between the highest and the second highest Population (in %) of Italy?
Your answer should be compact. 0.06. What is the difference between the highest and the second highest Population (in %) of Puerto Rico?
Ensure brevity in your answer.  0.7. What is the difference between the highest and the second highest Population (in %) in Sweden?
Keep it short and to the point. 0.01. What is the difference between the highest and the lowest Population (in %) of Estonia?
Keep it short and to the point. 0.39. What is the difference between the highest and the lowest Population (in %) in Italy?
Your answer should be very brief. 0.77. What is the difference between the highest and the lowest Population (in %) in Puerto Rico?
Ensure brevity in your answer.  3.31. What is the difference between the highest and the lowest Population (in %) in Sweden?
Keep it short and to the point. 0.32. 